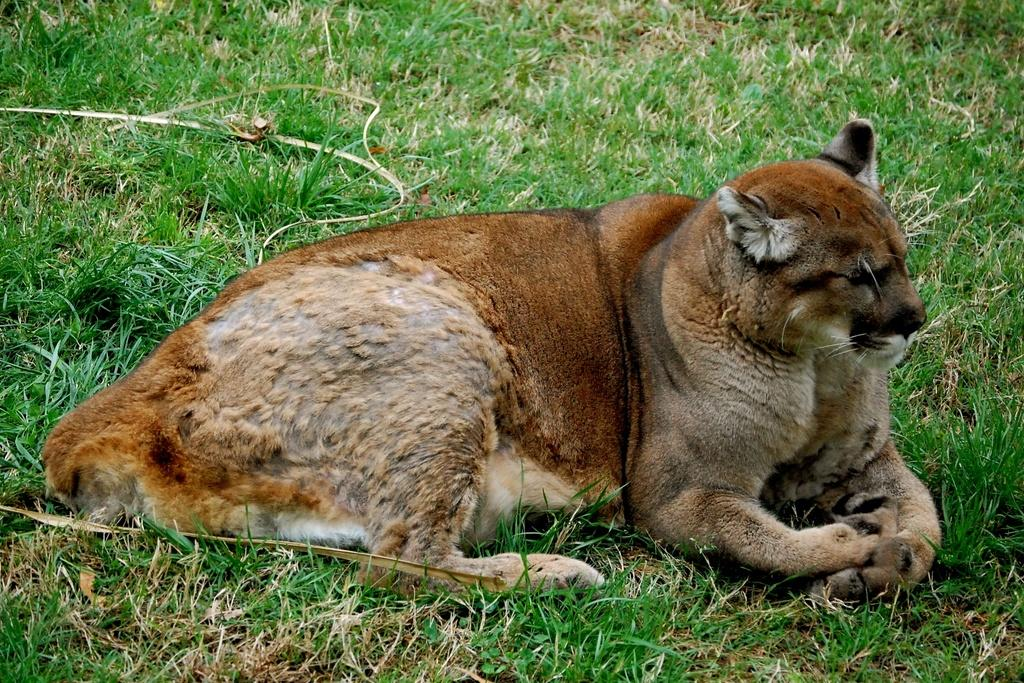What type of creature is in the image? There is an animal in the image. Where is the animal located? The animal is sitting on the grass. What type of polish is the animal using to shine its fur in the image? There is no polish or indication of the animal grooming itself in the image. 